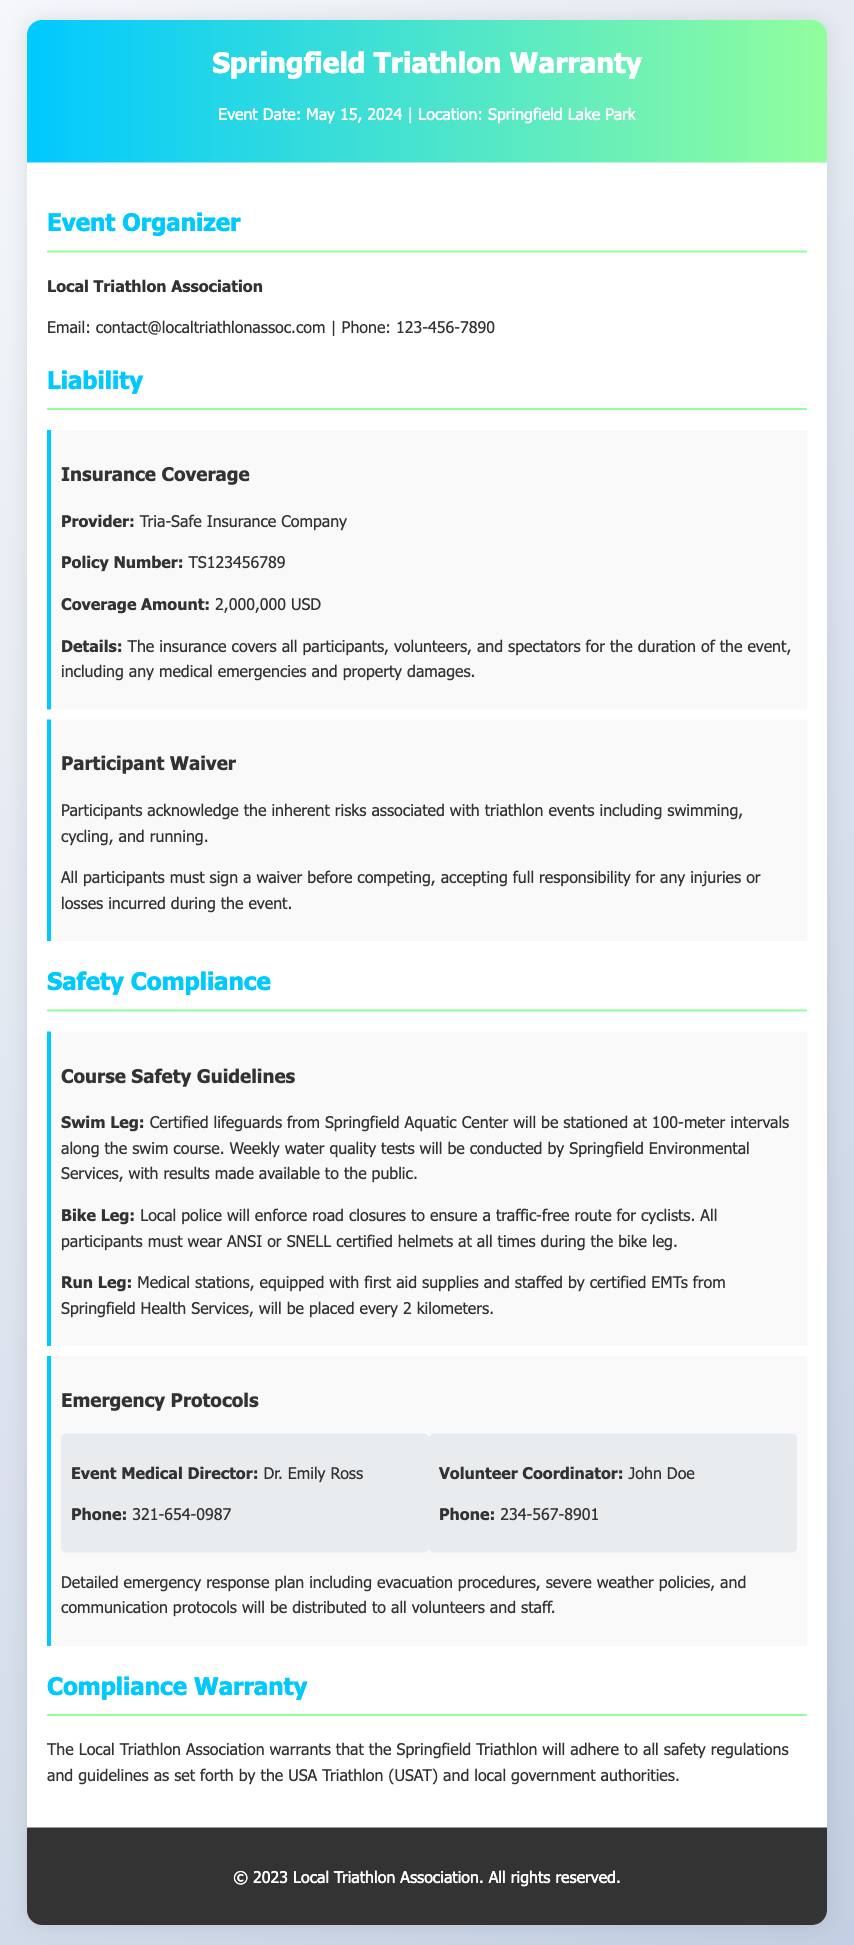What is the event date? The event date is mentioned in the header of the document.
Answer: May 15, 2024 Who is the event organizer? The organizer is specifically named in the event organizer section.
Answer: Local Triathlon Association What is the insurance coverage amount? The coverage amount is stated under the insurance coverage subsection.
Answer: 2,000,000 USD What must participants sign before competing? This is mentioned in the participant waiver subsection of the liability section.
Answer: A waiver How often will water quality tests be conducted? The frequency of testing is given in the course safety guidelines regarding the swim leg.
Answer: Weekly Who is the Event Medical Director? This person's name is specifically stated under emergency protocols.
Answer: Dr. Emily Ross What certification must participants' helmets have? This requirement is detailed in the bike leg safety guidelines.
Answer: ANSI or SNELL certified What does the Local Triathlon Association warrant? This is summarized in the compliance warranty section of the document.
Answer: Adhere to all safety regulations How far apart are medical stations on the run leg? This distance is specified in the run leg safety guidelines.
Answer: Every 2 kilometers 